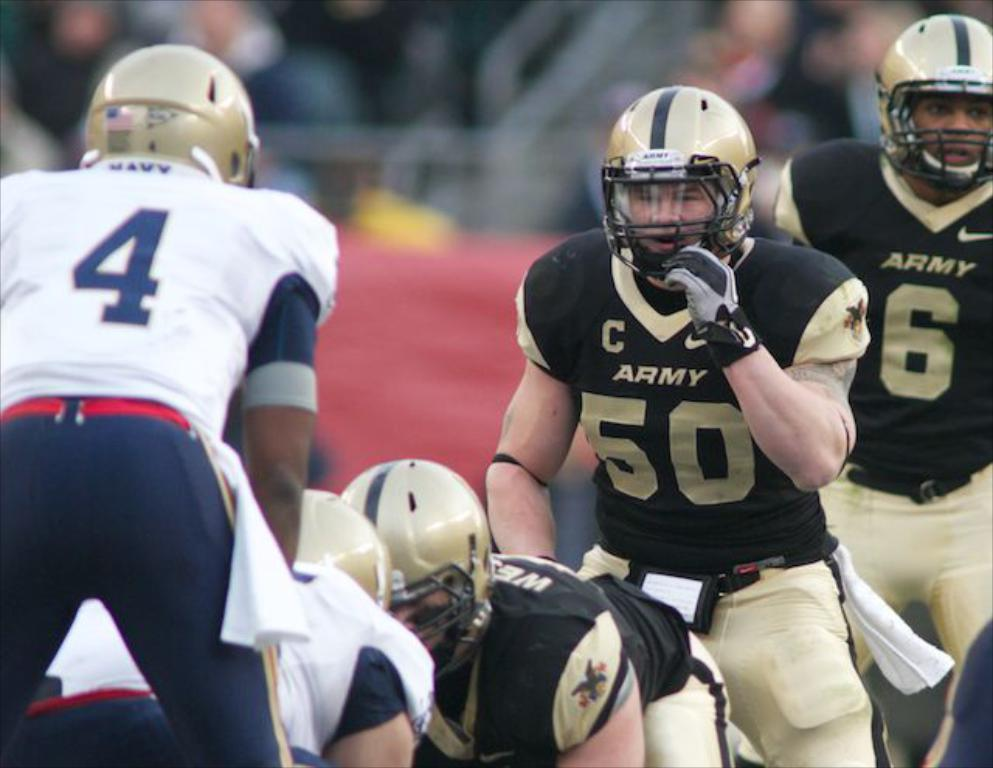Where was the image taken? The image was taken in a playground. What can be seen in the image besides the playground? There is a group of people in the image. What are the people wearing in the image? The people are wearing helmets. What colors are visible in the background of the image? There is a black color and a red color visible in the background of the image. What type of surprise is being prepared by the people in the image? There is no indication of a surprise in the image; the people are simply wearing helmets. Can you tell me which part of the playground is being used by the people in the image? The image does not show a specific part of the playground being used by the people; it only shows a group of people wearing helmets. 